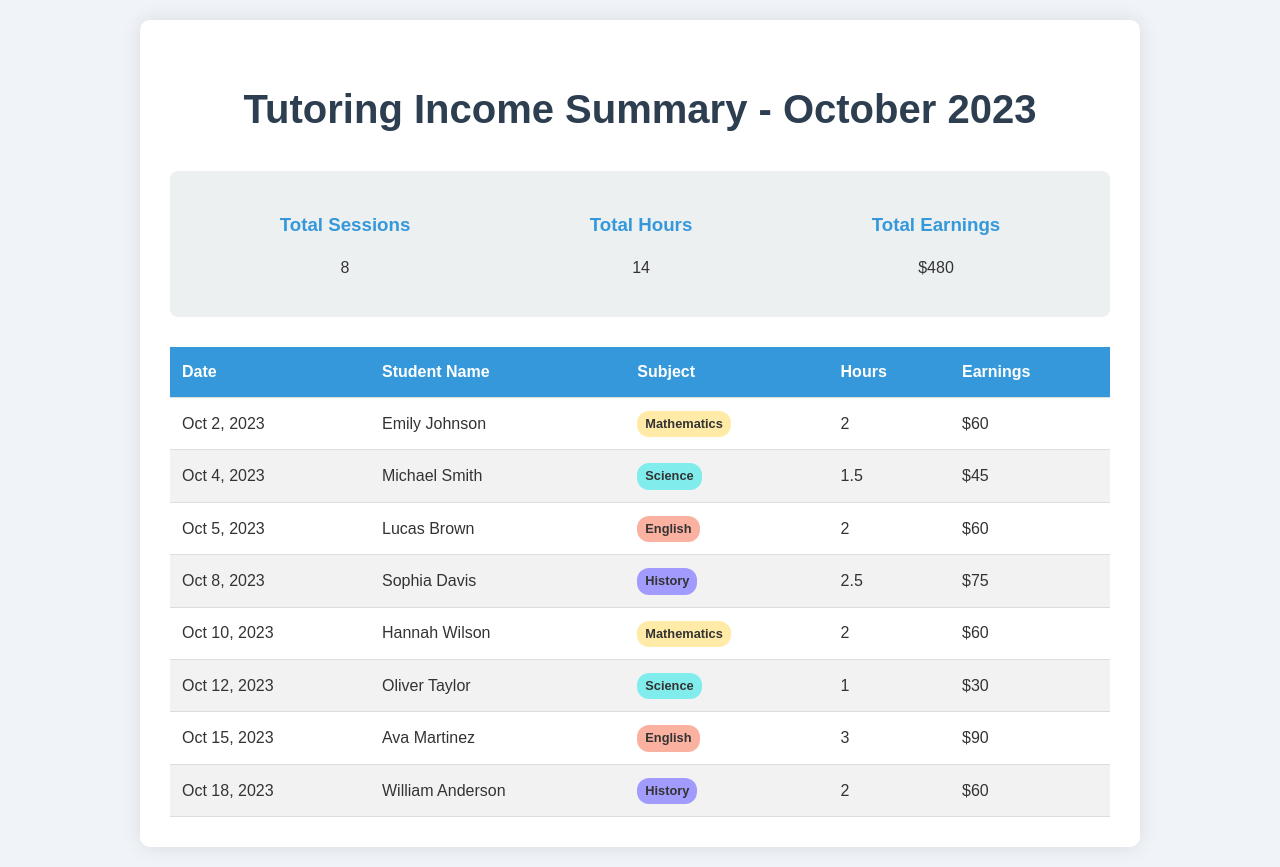What is the total sessions? The total sessions is listed as 8 in the summary section of the document.
Answer: 8 What is the total earnings? The total earnings amount is shown as $480 in the summary section of the document.
Answer: $480 Who is the student with the highest earnings? By reviewing the earnings for each student, Ava Martinez has the highest earnings of $90.
Answer: Ava Martinez On what date did you tutor Hannah Wilson? The date of tutoring for Hannah Wilson is provided as October 10, 2023.
Answer: Oct 10, 2023 How many hours did you tutor William Anderson? The table shows that William Anderson had 2 hours of tutoring.
Answer: 2 What subjects were taught during the sessions? The document lists Mathematics, Science, English, and History as subjects taught.
Answer: Mathematics, Science, English, History How many total hours were spent tutoring? The total hours mentioned in the summary is 14, indicating the overall tutoring time.
Answer: 14 Which session earned the least money? The session with the least earnings is Oliver Taylor, with earnings of $30.
Answer: $30 What is the date of the last tutoring session? The last tutoring session recorded in the table is on October 18, 2023.
Answer: Oct 18, 2023 